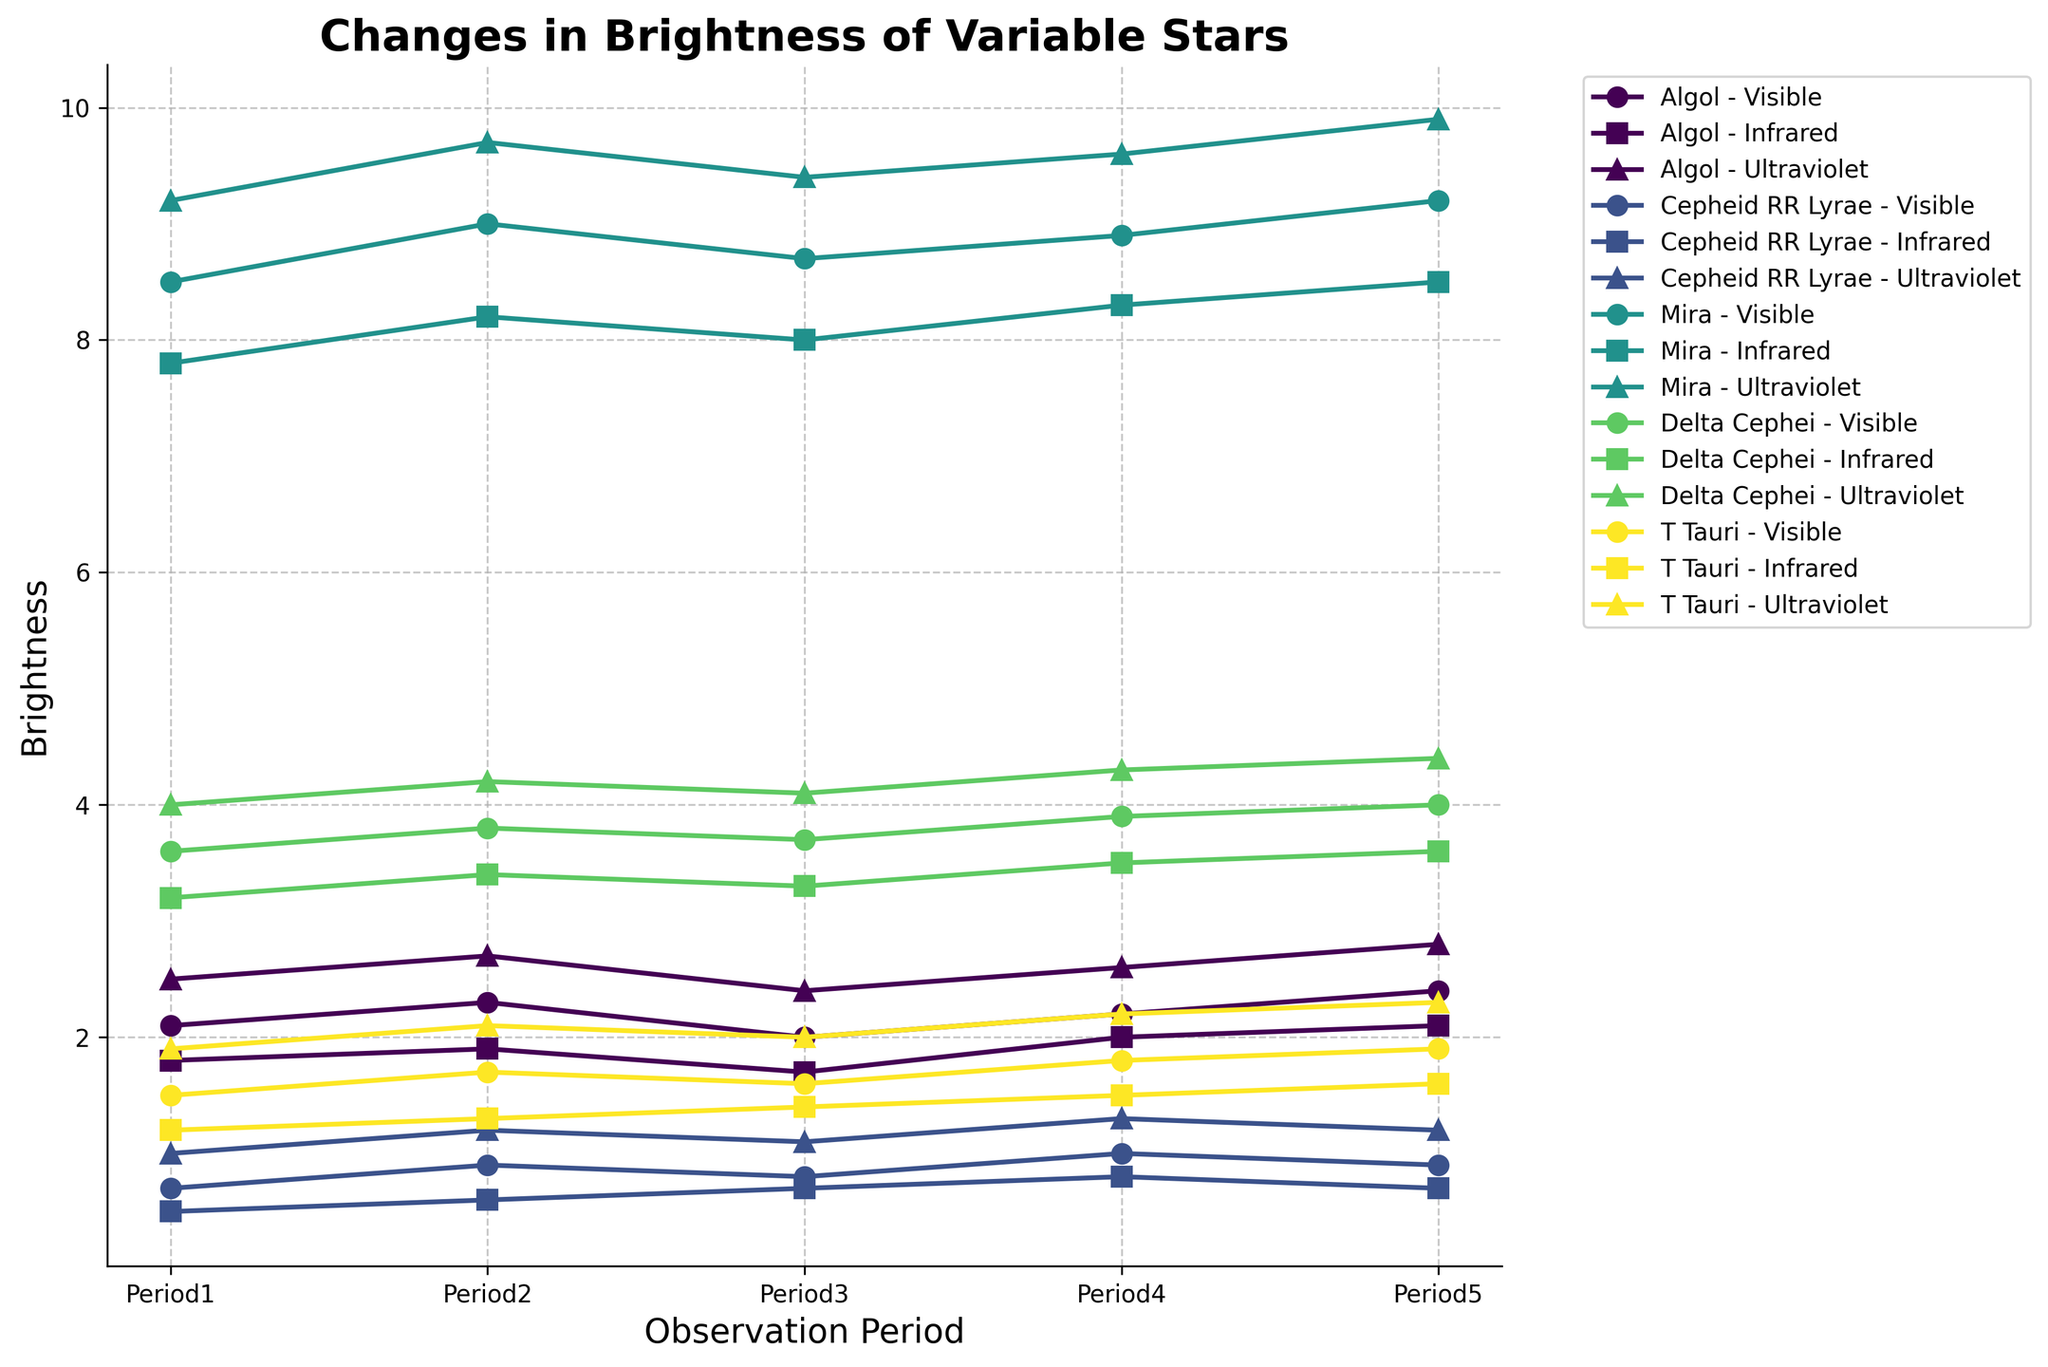What is the brightness of Mira in the visible wavelength during Period 1? Locate the line labeled "Mira - Visible" on the chart, then find the value corresponding to "Period1".
Answer: 8.5 Which star has the highest brightness in the ultraviolet wavelength during Period 5? Locate the lines labeled with the "Ultraviolet" wavelength and then identify the star with the highest value at "Period5".
Answer: Mira What is the average brightness of Delta Cephei in the infrared wavelength across all observation periods? Find the line labeled "Delta Cephei - Infrared", sum the brightness values across all periods (3.2, 3.4, 3.3, 3.5, 3.6), and divide by the number of periods. (3.2 + 3.4 + 3.3 + 3.5 + 3.6)/5 = 3.4
Answer: 3.4 Compare the brightness of Algol in visible and infrared wavelengths during Period 3. Which is greater? Find the lines "Algol - Visible" and "Algol - Infrared" and compare the values at "Period3". 2.0 (Visible) vs 1.7 (Infrared)
Answer: Visible By how much does the brightness of T Tauri change in the ultraviolet wavelength from Period 1 to Period 5? Locate the line "T Tauri - Ultraviolet" and find the brightness values at "Period1" and "Period5". Compute the difference: 2.3 - 1.9 = 0.4.
Answer: 0.4 Which wavelength shows the most consistent brightness change for Cepheid RR Lyrae across all observation periods? Find the lines "Cepheid RR Lyrae - Visible", "Cepheid RR Lyrae - Infrared", and "Cepheid RR Lyrae - Ultraviolet". Compare the variability of each line. Infrared shows relatively smaller changes compared to others.
Answer: Infrared What is the difference in brightness between Period 2 and Period 4 for T Tauri in the visible wavelength? Locate "T Tauri - Visible" and find the brightness values at "Period2" and "Period4". Compute the difference: 1.8 - 1.7 = 0.1.
Answer: 0.1 Which star shows the greatest increase in brightness in the visible wavelength from Period 1 to Period 5? For each star in the visible wavelength, calculate the brightness increase from "Period1" to "Period5". Mira's increase is the greatest: 9.2 - 8.5 = 0.7.
Answer: Mira Does Algol show a greater change in brightness in the ultraviolet wavelength from Period 2 to Period 4, or Delta Cephei in the same wavelength over the same periods? Calculate the brightness change for Algol and Delta Cephei in the ultraviolet wavelength: Algol (2.6 - 2.7 = -0.1), Delta Cephei (4.3 - 4.2 = 0.1). Compare the absolute values.
Answer: Delta Cephei What is the total brightness of Cepheid RR Lyrae in the visible wavelength over all observation periods? Sum the brightness values for "Cepheid RR Lyrae - Visible" across all periods: 0.7 + 0.9 + 0.8 + 1.0 + 0.9 = 4.3.
Answer: 4.3 